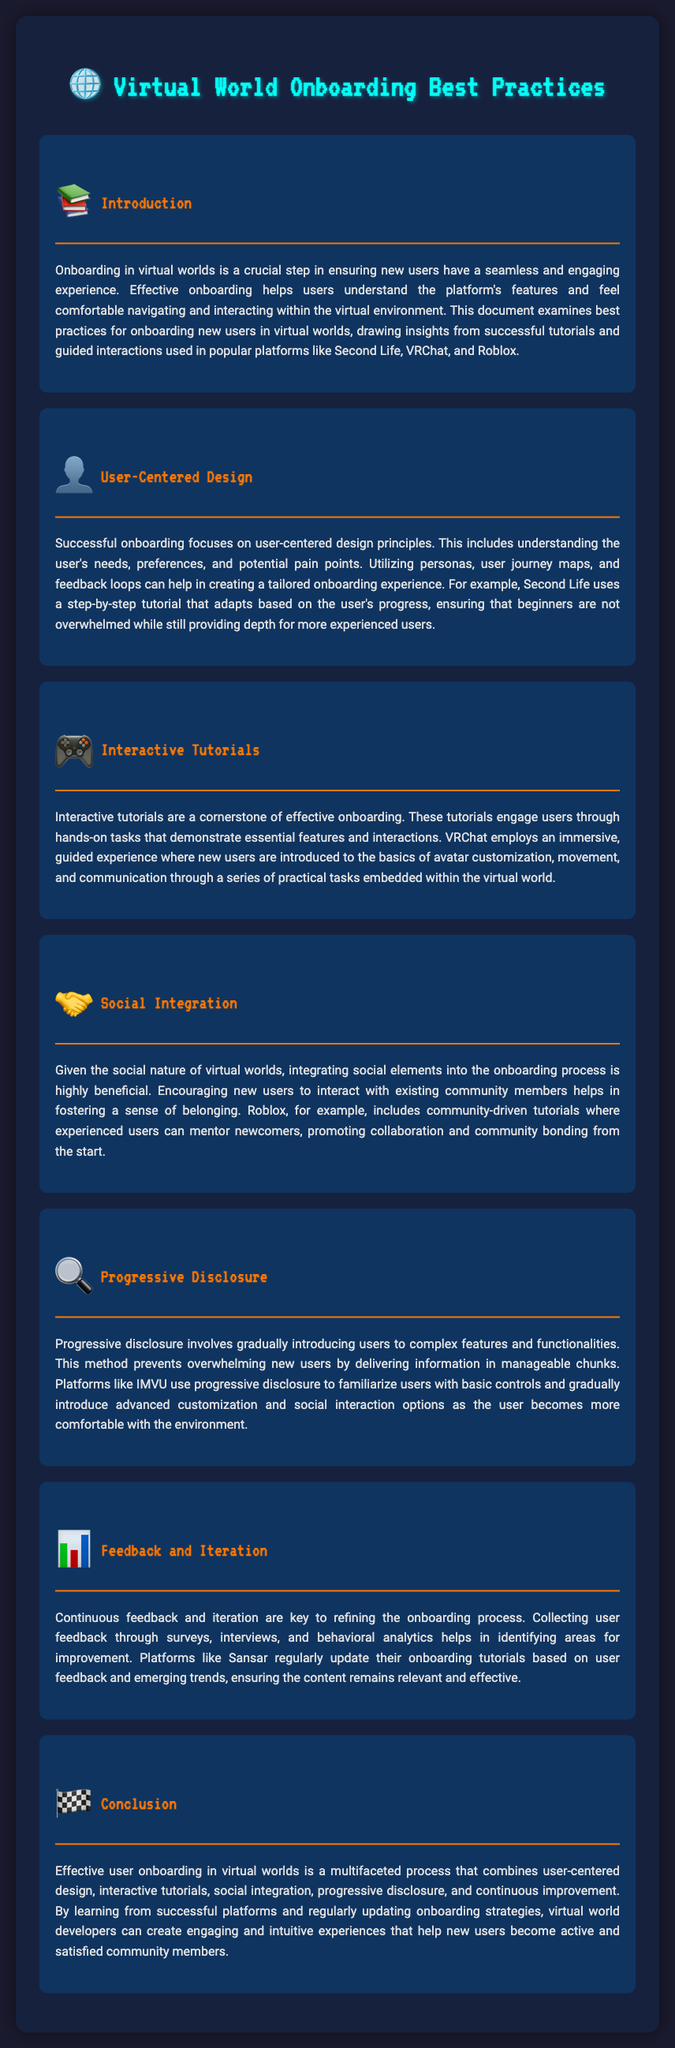What is the main focus of onboarding in virtual worlds? The main focus is to ensure new users have a seamless and engaging experience by understanding the platform's features.
Answer: Seamless and engaging experience Which platform uses a step-by-step tutorial that adapts based on user progress? The document mentions that Second Life employs a step-by-step tutorial that adapts to user progress.
Answer: Second Life What are the five key elements of effective user onboarding mentioned? The five key elements are user-centered design, interactive tutorials, social integration, progressive disclosure, and feedback and iteration.
Answer: User-centered design, interactive tutorials, social integration, progressive disclosure, feedback and iteration What principle does progressive disclosure rely on? Progressive disclosure relies on gradually introducing users to complex features to prevent overwhelming them.
Answer: Gradually introducing users Which platform includes community-driven tutorials for mentoring newcomers? The document states that Roblox includes community-driven tutorials for this purpose.
Answer: Roblox What type of feedback is crucial for refining the onboarding process? Continuous feedback through surveys, interviews, and behavioral analytics is crucial for refinement.
Answer: Continuous feedback What is the aim of incorporating social integration in onboarding? The aim is to foster a sense of belonging for new users in the community.
Answer: Sense of belonging Which platform updates its onboarding tutorials based on user feedback? Sansar regularly updates its onboarding tutorials according to user feedback.
Answer: Sansar 